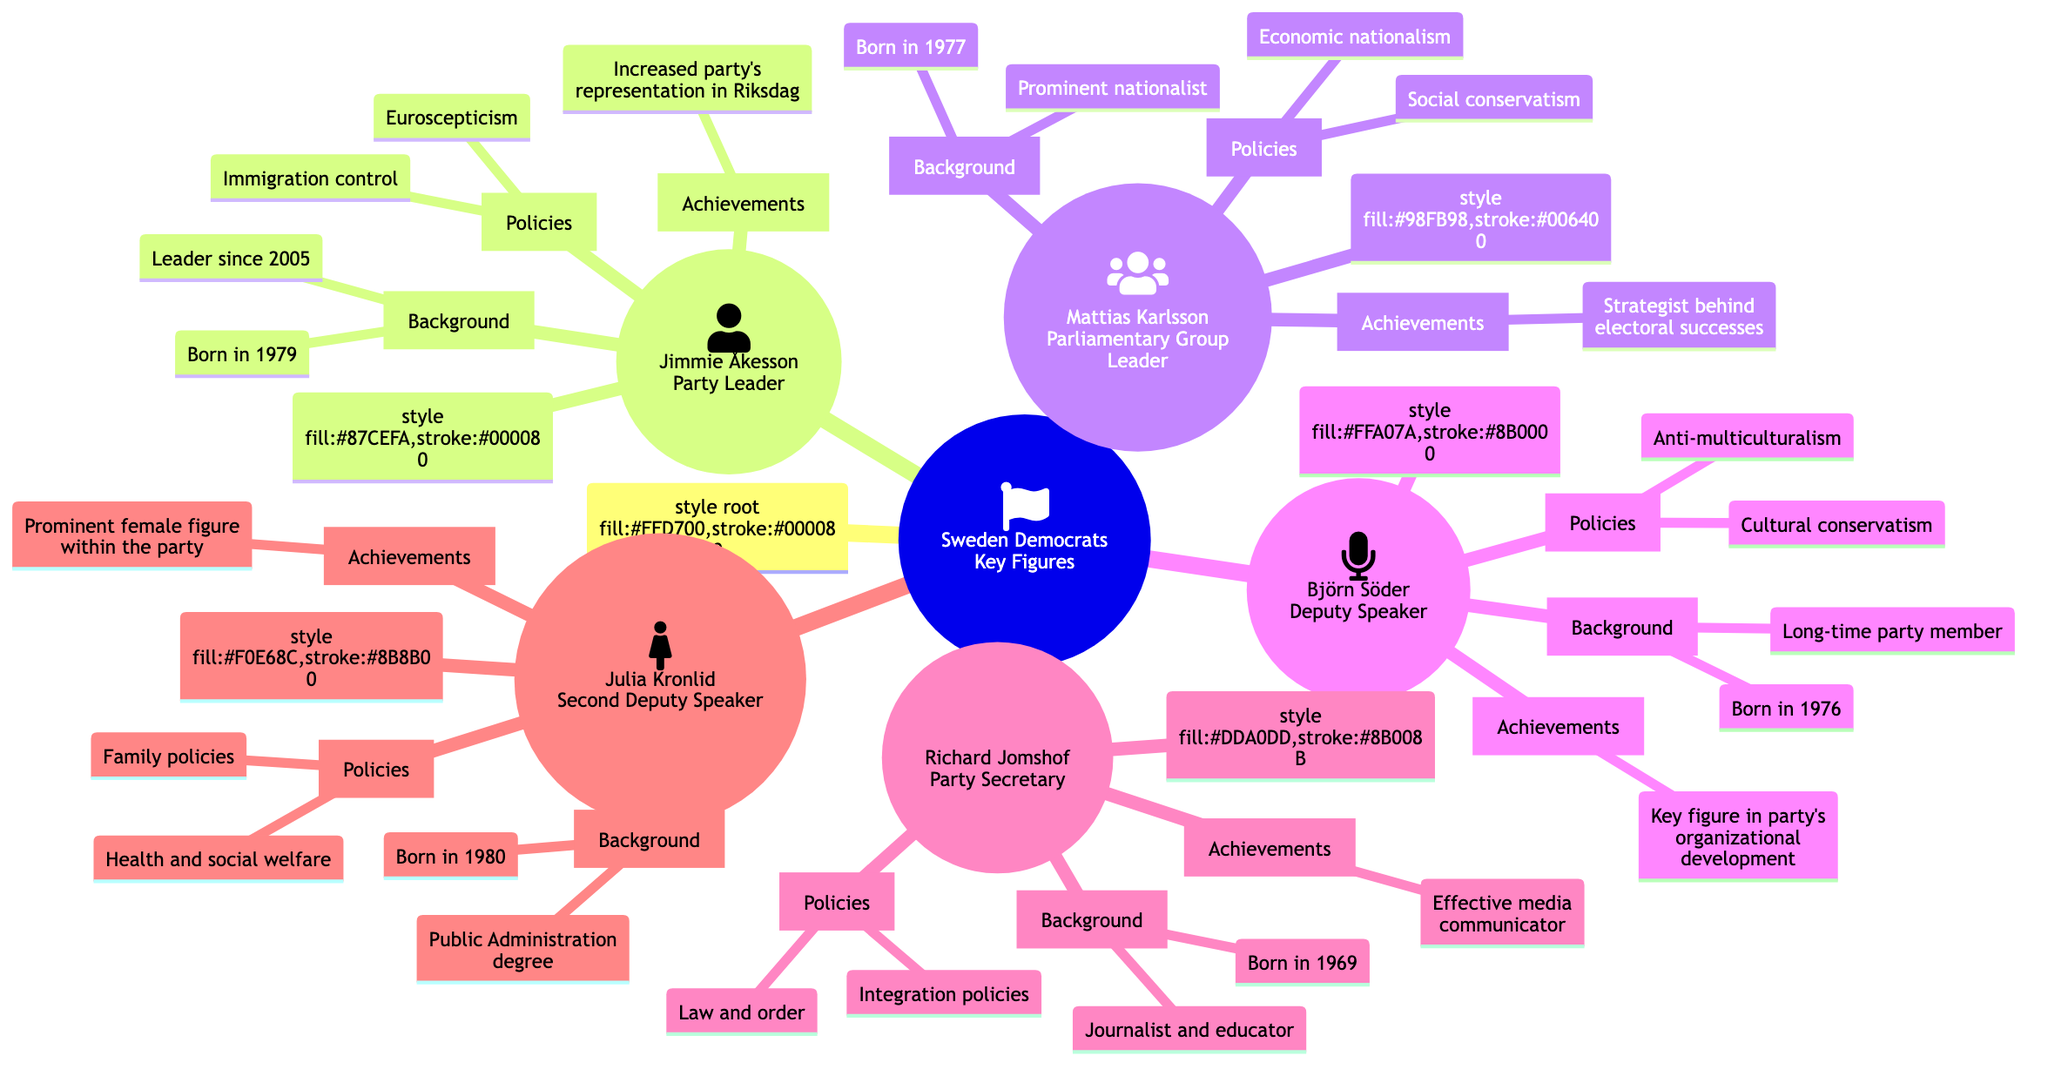What is the role of Jimmie Åkesson? Jimmie Åkesson is labeled as the Party Leader in the diagram.
Answer: Party Leader How many key political figures are listed in the diagram? The diagram contains five key figures: Jimmie Åkesson, Mattias Karlsson, Björn Söder, Richard Jomshof, and Julia Kronlid.
Answer: 5 What policy focus is emphasized by Richard Jomshof? Richard Jomshof's policy focus, as indicated in the diagram, is on law and order and integration policies.
Answer: Law and order Who is the prominent female figure within the Sweden Democrats? Julia Kronlid is mentioned in the diagram as the prominent female figure within the party.
Answer: Julia Kronlid Which key figure has a degree in Public Administration? The diagram specifies that Julia Kronlid holds a degree in Public Administration.
Answer: Julia Kronlid What achievement is noted for Mattias Karlsson? The diagram attribute the achievement of being the strategist behind electoral successes to Mattias Karlsson.
Answer: Strategist behind electoral successes What policies does Björn Söder focus on? According to the diagram, Björn Söder focuses on cultural conservatism and anti-multiculturalism.
Answer: Cultural conservatism, anti-multiculturalism Who has been the leader of the Sweden Democrats since 2005? The diagram directly states that Jimmie Åkesson has been the leader since 2005.
Answer: Jimmie Åkesson What is the background of Richard Jomshof? Richard Jomshof’s background involves being a journalist and educator, as stated in the diagram.
Answer: Journalist and educator 